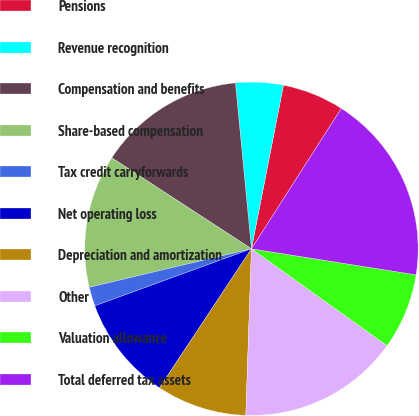Convert chart to OTSL. <chart><loc_0><loc_0><loc_500><loc_500><pie_chart><fcel>Pensions<fcel>Revenue recognition<fcel>Compensation and benefits<fcel>Share-based compensation<fcel>Tax credit carryforwards<fcel>Net operating loss<fcel>Depreciation and amortization<fcel>Other<fcel>Valuation allowance<fcel>Total deferred tax assets<nl><fcel>5.99%<fcel>4.61%<fcel>14.28%<fcel>12.9%<fcel>1.85%<fcel>10.14%<fcel>8.76%<fcel>15.66%<fcel>7.38%<fcel>18.43%<nl></chart> 